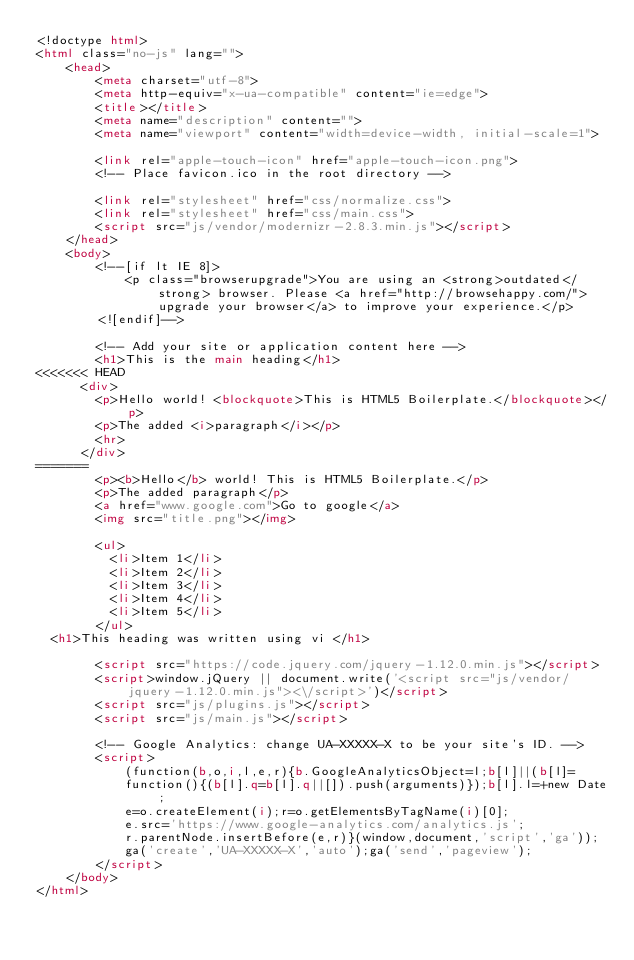<code> <loc_0><loc_0><loc_500><loc_500><_HTML_><!doctype html>
<html class="no-js" lang="">
    <head>
        <meta charset="utf-8">
        <meta http-equiv="x-ua-compatible" content="ie=edge">
        <title></title>
        <meta name="description" content="">
        <meta name="viewport" content="width=device-width, initial-scale=1">

        <link rel="apple-touch-icon" href="apple-touch-icon.png">
        <!-- Place favicon.ico in the root directory -->

        <link rel="stylesheet" href="css/normalize.css">
        <link rel="stylesheet" href="css/main.css">
        <script src="js/vendor/modernizr-2.8.3.min.js"></script>
    </head>
    <body>
        <!--[if lt IE 8]>
            <p class="browserupgrade">You are using an <strong>outdated</strong> browser. Please <a href="http://browsehappy.com/">upgrade your browser</a> to improve your experience.</p>
        <![endif]-->

        <!-- Add your site or application content here -->
        <h1>This is the main heading</h1>
<<<<<<< HEAD
      <div>
        <p>Hello world! <blockquote>This is HTML5 Boilerplate.</blockquote></p>
        <p>The added <i>paragraph</i></p>
        <hr>
      </div>
=======
        <p><b>Hello</b> world! This is HTML5 Boilerplate.</p>
        <p>The added paragraph</p>
        <a href="www.google.com">Go to google</a>
        <img src="title.png"></img>

        <ul>
          <li>Item 1</li>
          <li>Item 2</li>
          <li>Item 3</li>
          <li>Item 4</li>
          <li>Item 5</li>
        </ul>
	<h1>This heading was written using vi </h1>

        <script src="https://code.jquery.com/jquery-1.12.0.min.js"></script>
        <script>window.jQuery || document.write('<script src="js/vendor/jquery-1.12.0.min.js"><\/script>')</script>
        <script src="js/plugins.js"></script>
        <script src="js/main.js"></script>

        <!-- Google Analytics: change UA-XXXXX-X to be your site's ID. -->
        <script>
            (function(b,o,i,l,e,r){b.GoogleAnalyticsObject=l;b[l]||(b[l]=
            function(){(b[l].q=b[l].q||[]).push(arguments)});b[l].l=+new Date;
            e=o.createElement(i);r=o.getElementsByTagName(i)[0];
            e.src='https://www.google-analytics.com/analytics.js';
            r.parentNode.insertBefore(e,r)}(window,document,'script','ga'));
            ga('create','UA-XXXXX-X','auto');ga('send','pageview');
        </script>
    </body>
</html>
</code> 